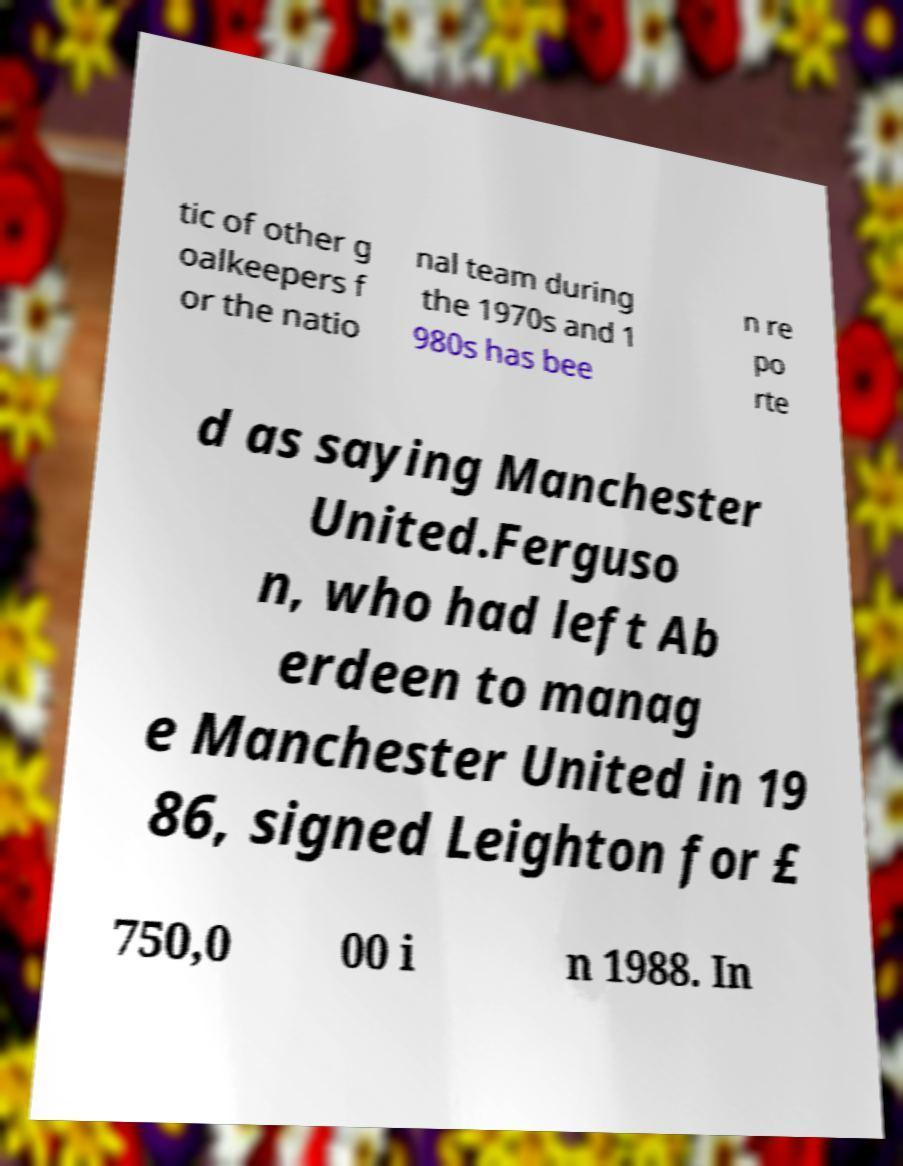There's text embedded in this image that I need extracted. Can you transcribe it verbatim? tic of other g oalkeepers f or the natio nal team during the 1970s and 1 980s has bee n re po rte d as saying Manchester United.Ferguso n, who had left Ab erdeen to manag e Manchester United in 19 86, signed Leighton for £ 750,0 00 i n 1988. In 